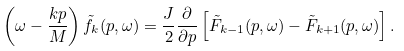Convert formula to latex. <formula><loc_0><loc_0><loc_500><loc_500>\left ( \omega - \frac { k p } { M } \right ) \tilde { f } _ { k } ( p , \omega ) = \frac { J } { 2 } \frac { \partial } { \partial p } \left [ { \tilde { F } } _ { k - 1 } ( p , \omega ) - { \tilde { F } } _ { k + 1 } ( p , \omega ) \right ] .</formula> 